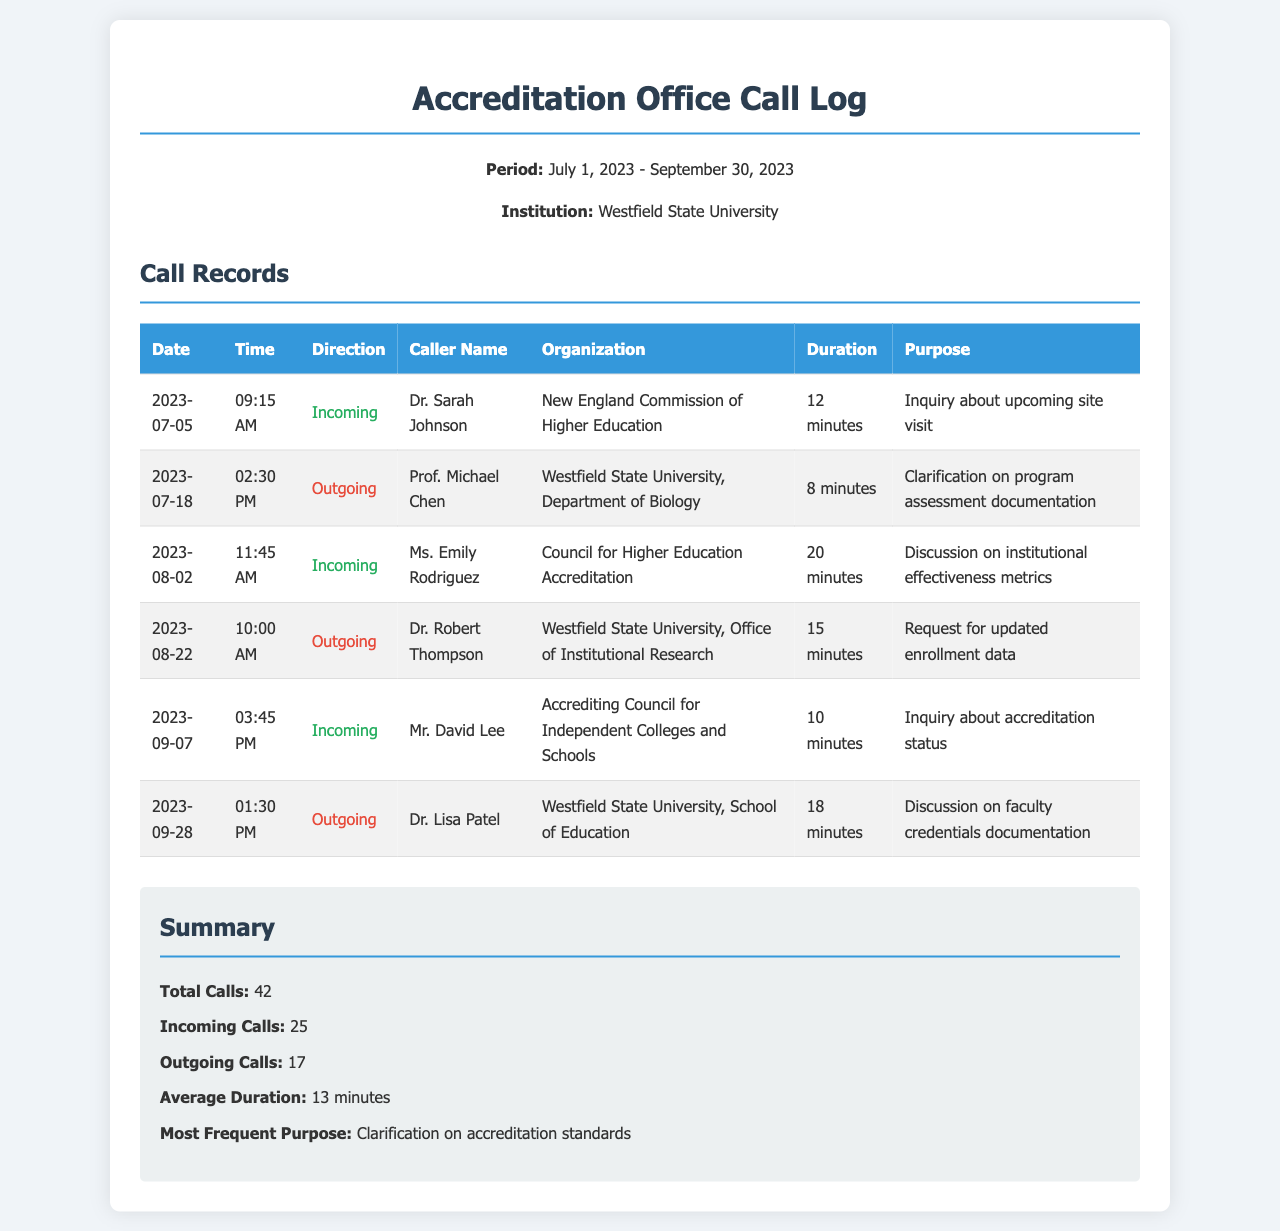what is the total number of calls? The total number of calls is provided in the summary section of the document, which states the total calls as 42.
Answer: 42 who called on July 5, 2023? The name of the caller on this date is included in the call records. It states that Dr. Sarah Johnson made an incoming call.
Answer: Dr. Sarah Johnson what was the purpose of the call from Ms. Emily Rodriguez? The purpose of her call is detailed in the call records and specifies a discussion on institutional effectiveness metrics.
Answer: Discussion on institutional effectiveness metrics how long was the call on August 22, 2023? The duration of the call is mentioned in the table for that date, which indicates it lasted for 15 minutes.
Answer: 15 minutes how many outgoing calls were made during this period? This information is summarized under the total outgoing calls in the summary section, which notes there are 17 outgoing calls.
Answer: 17 who was the caller from the Accrediting Council for Independent Colleges and Schools? The document provides the caller's name, which specifies Mr. David Lee made the call.
Answer: Mr. David Lee what is the date of the longest call? The call records do not specify exact durations in the table, but reasoning through the call durations listed reveals that Ms. Emily Rodriguez’s call lasted the longest at 20 minutes on August 2, 2023.
Answer: August 2, 2023 what organization does Dr. Lisa Patel belong to? The organization is provided in the call log, indicating that she belongs to the Westfield State University, School of Education.
Answer: Westfield State University, School of Education 